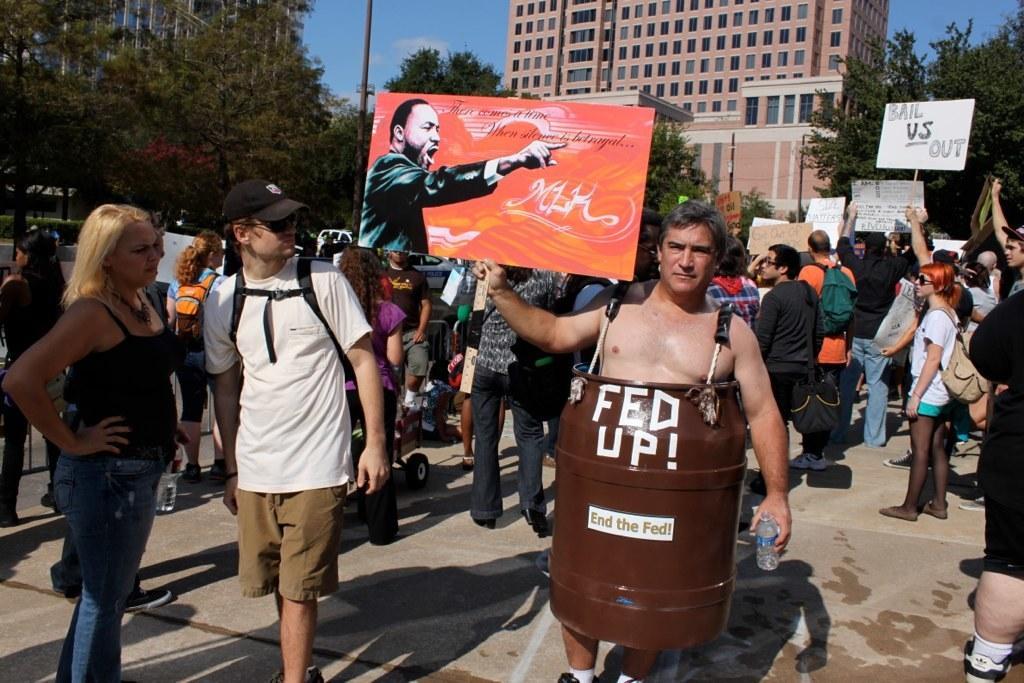How would you summarize this image in a sentence or two? There are people in the foreground area of the image holding posters in their hands and there are trees, buildings, vehicles, pole and sky in the background area. 